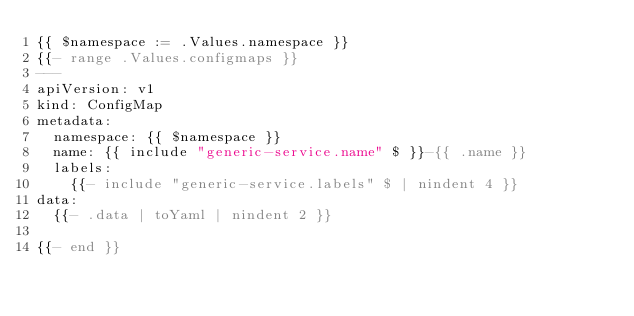Convert code to text. <code><loc_0><loc_0><loc_500><loc_500><_YAML_>{{ $namespace := .Values.namespace }}
{{- range .Values.configmaps }}
---
apiVersion: v1
kind: ConfigMap
metadata:
  namespace: {{ $namespace }}
  name: {{ include "generic-service.name" $ }}-{{ .name }}
  labels:
    {{- include "generic-service.labels" $ | nindent 4 }}
data:
  {{- .data | toYaml | nindent 2 }}

{{- end }}

</code> 